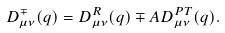<formula> <loc_0><loc_0><loc_500><loc_500>D ^ { \mp } _ { \mu \nu } ( q ) = D ^ { R } _ { \mu \nu } ( q ) \mp A D ^ { P T } _ { \mu \nu } ( q ) .</formula> 